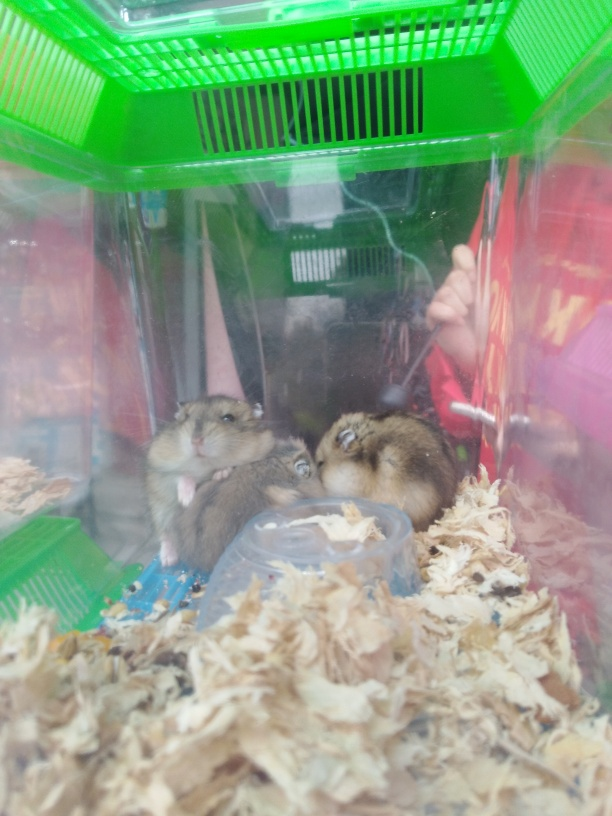The enclosure seems quite small; does that affect the hamsters? Hamsters need sufficient space to express natural behaviors, and small enclosures can lead to stress and health issues. A larger habitat with areas to explore, hide, and exercise is essential for their well-being. If this cage is temporary, such as for transportation, it would be less of a concern, but as a permanent living space, it would be inadequate. How could the image clarity be improved in a situation like this? Improving image clarity in this scenario could involve cleaning the camera lens to remove smudges, using a camera with a higher resolution, stabilizing the camera to prevent motion blur, ensuring adequate lighting to avoid graininess, and if the enclosure's walls are causing distortions, taking the photo from an angle that minimizes reflection and refraction. 